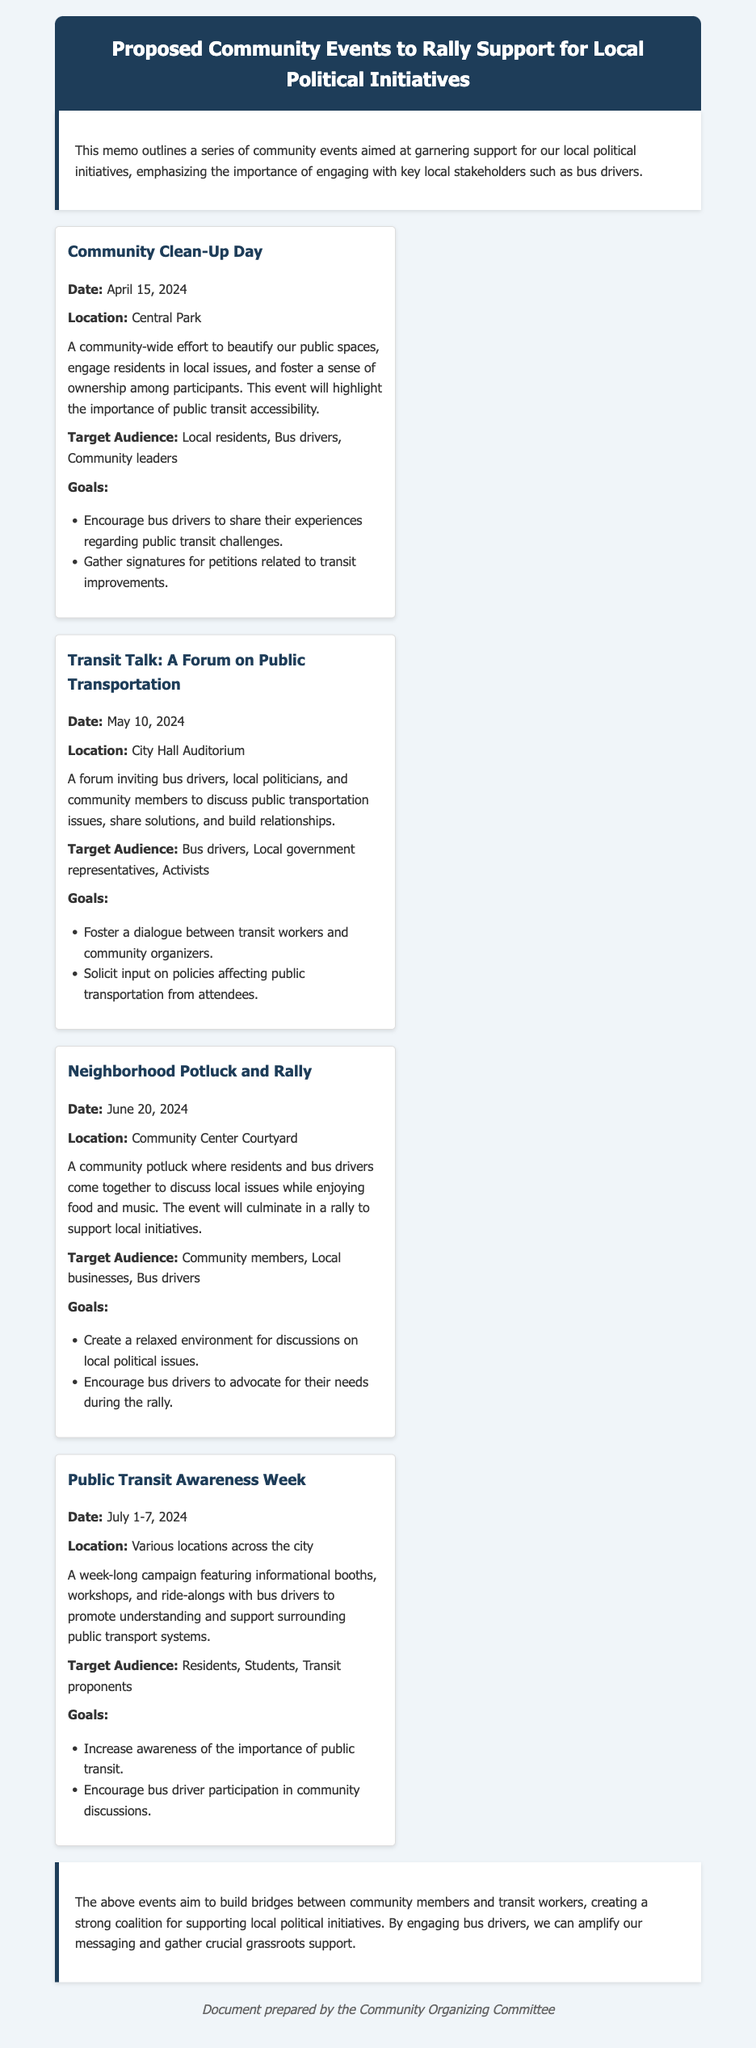What is the date of the Community Clean-Up Day? The date for the Community Clean-Up Day is specified in the document.
Answer: April 15, 2024 Where will the Transit Talk forum take place? The location for the Transit Talk forum is mentioned in the event details.
Answer: City Hall Auditorium What is a goal of the Neighborhood Potluck and Rally? The document lists specific goals for the Neighborhood Potluck and Rally event.
Answer: Create a relaxed environment for discussions on local political issues What is the duration of the Public Transit Awareness Week? The document specifies the date range for the Public Transit Awareness Week.
Answer: July 1-7, 2024 Who is the target audience for the Community Clean-Up Day? The document describes the target audience for each event.
Answer: Local residents, Bus drivers, Community leaders What type of event is the Transit Talk? The nature of the event is indicated in the document by its title and description.
Answer: A forum What is emphasized in the introduction of the memo? The introduction highlights the importance of engaging key stakeholders for the community events.
Answer: Engaging with key local stakeholders such as bus drivers How many events are proposed in the memo? The number of community events outlined can be counted in the document.
Answer: Four 